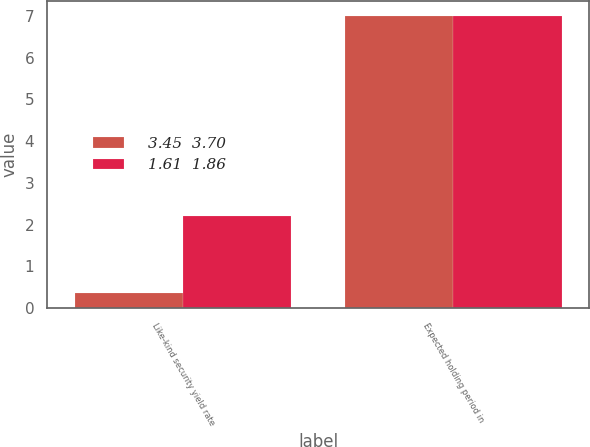<chart> <loc_0><loc_0><loc_500><loc_500><stacked_bar_chart><ecel><fcel>Like-kind security yield rate<fcel>Expected holding period in<nl><fcel>3.45  3.70<fcel>0.36<fcel>7<nl><fcel>1.61  1.86<fcel>2.2<fcel>7<nl></chart> 